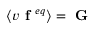Convert formula to latex. <formula><loc_0><loc_0><loc_500><loc_500>\left \langle v f ^ { e q } \right \rangle = G</formula> 